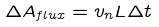Convert formula to latex. <formula><loc_0><loc_0><loc_500><loc_500>\Delta A _ { f l u x } = v _ { n } L \Delta t</formula> 